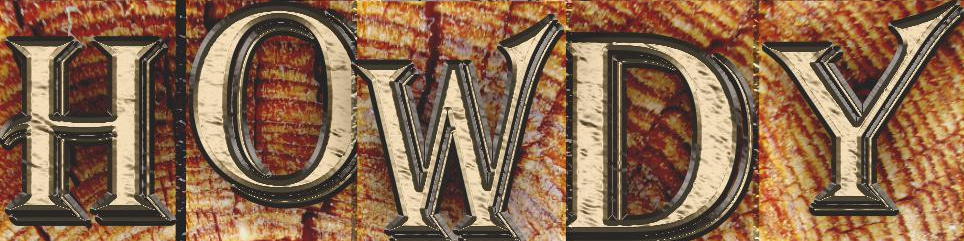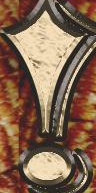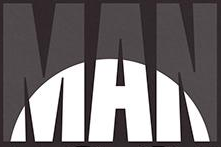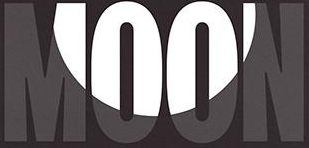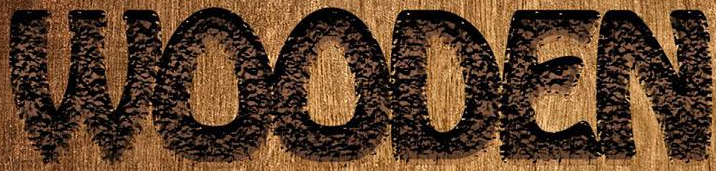Identify the words shown in these images in order, separated by a semicolon. HOWDY; !; MAN; MOON; WOODEN 